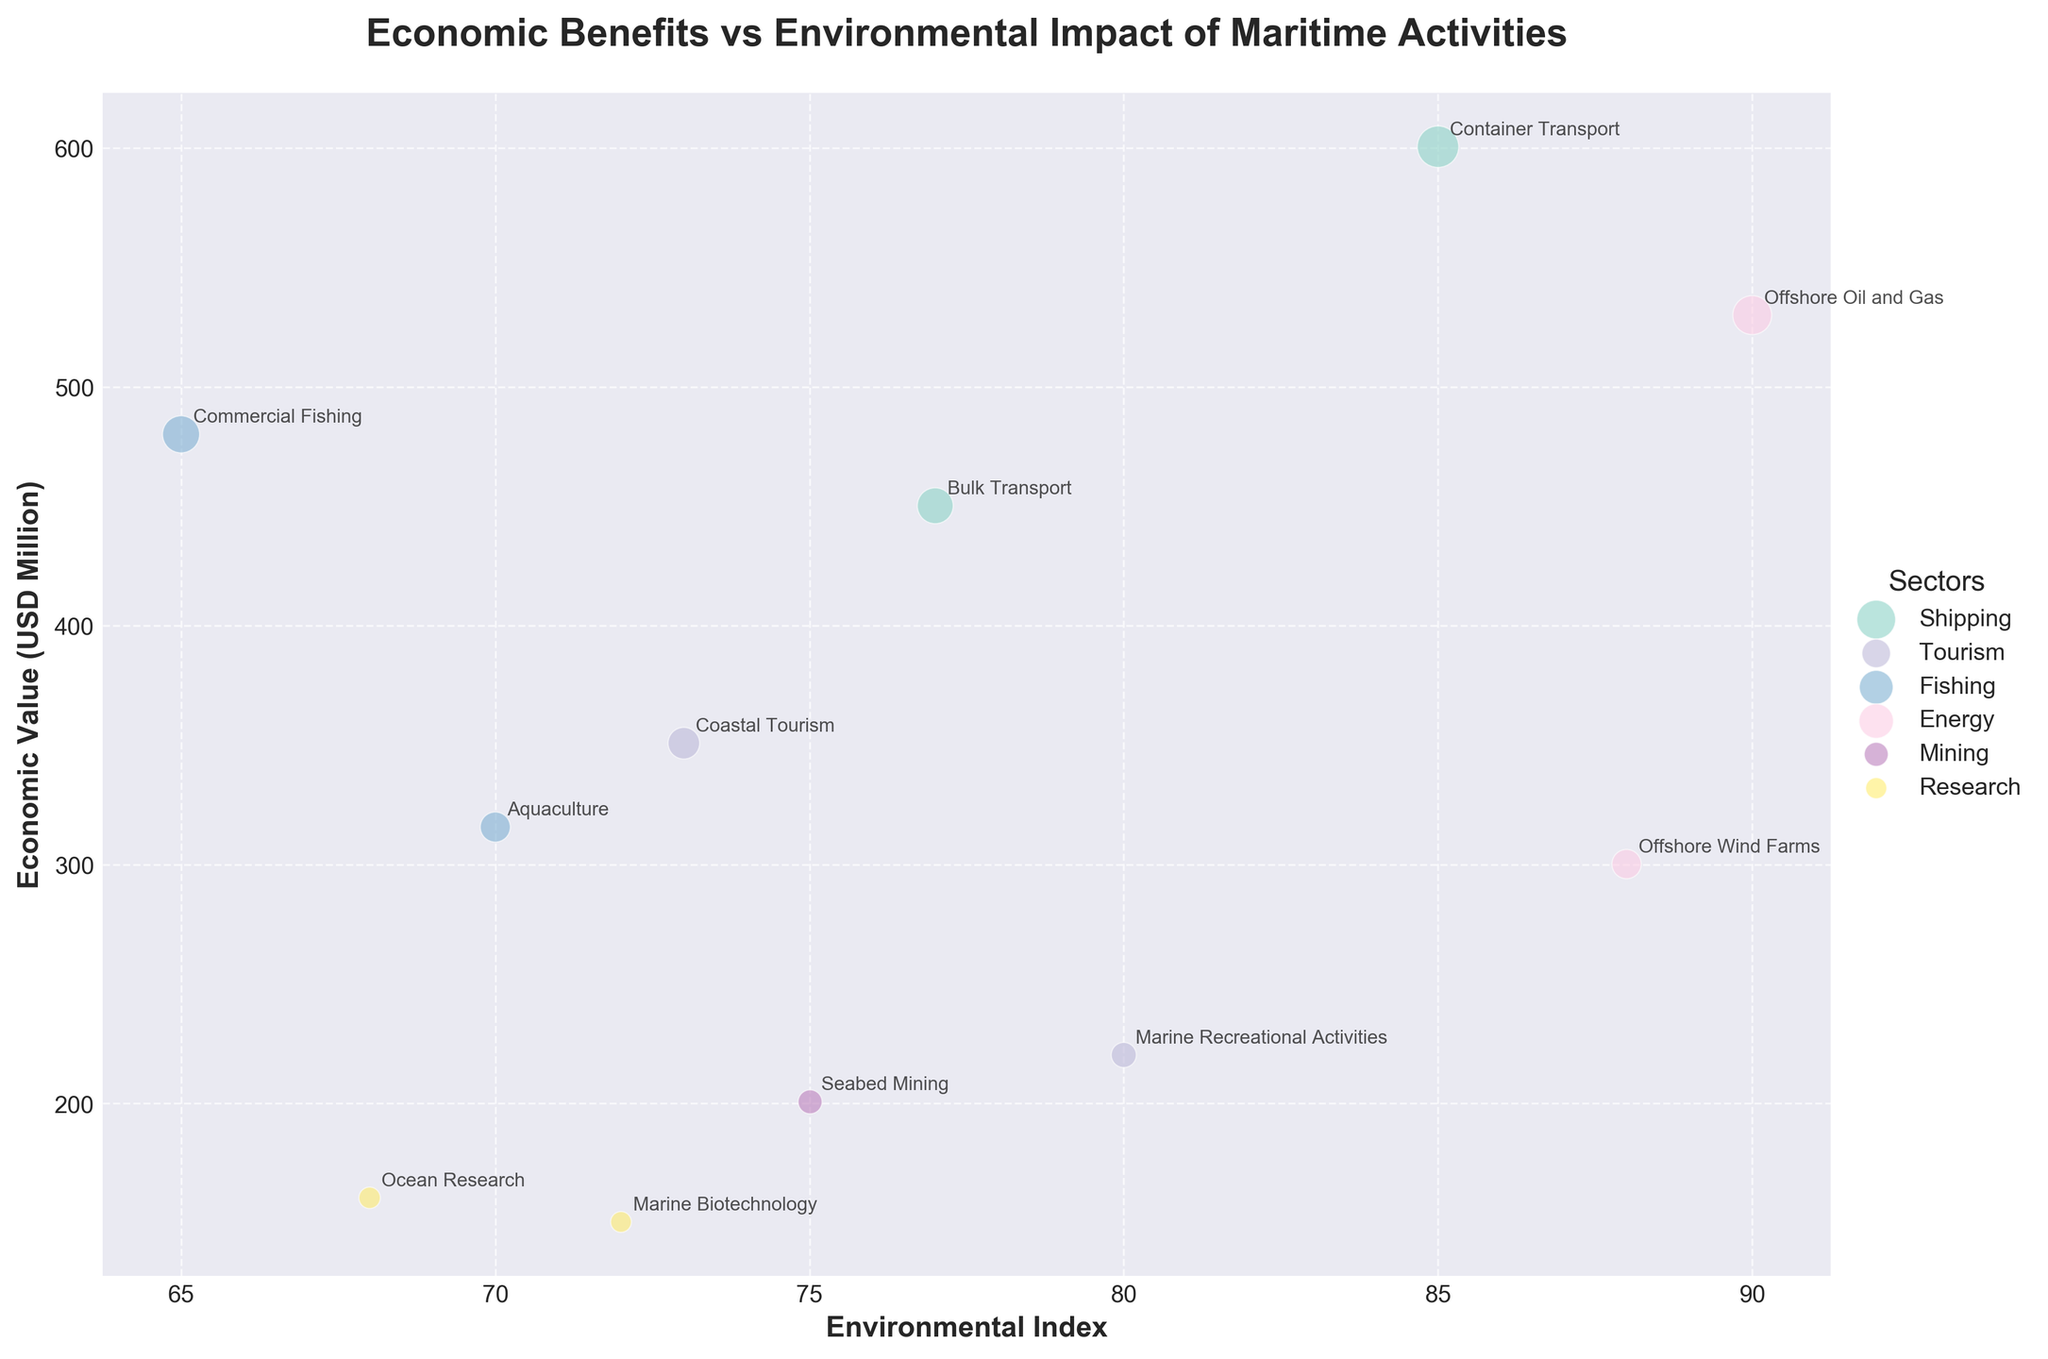What's the title of the chart? The title of the chart is displayed prominently at the top of the figure.
Answer: "Economic Benefits vs Environmental Impact of Maritime Activities" Which sector has the highest economic value? Identify the largest bubble on the vertical axis, which corresponds to the economic value. The "Offshore Oil and Gas" sector in Saudi Arabia has the highest value (530 USD Million).
Answer: Energy (Offshore Oil and Gas) How many different sectors are represented in the chart? Count the number of unique legends aside from the data points in the plot. There are 6 unique sectors (Shipping, Tourism, Fishing, Energy, Mining, Research).
Answer: 6 Which subsectors from the same country are depicted in the plot? Look for bubbles with similar colors and check their labels to see which country they belong to. Both "Ocean Research" and "Marine Biotechnology" subsectors from Canada are depicted.
Answer: Marine Biotechnology and Ocean Research Which sector has both the highest economic value and high environmental index? Cross-reference the highest economic value with corresponding environmental indices on the plot. The "Offshore Oil and Gas" sector has the highest economic value and a high environmental index of 90.
Answer: Energy (Offshore Oil and Gas) What is the average economic value of the tourism sector? Identify the economic values for all subsectors under "Tourism", then compute the average. (350.8 + 220.3) / 2 = 285.55 USD Million.
Answer: 285.55 Compare the economic values of "Commercial Fishing" in Japan and "Bulk Transport" in China. Which is higher? Locate both bubbles and compare their vertical positions to determine which economic value is higher. "Commercial Fishing" in Japan (480.1) is higher than "Bulk Transport" in China (450.2).
Answer: Commercial Fishing Which sector has the lowest environmental index? Identify the bubble with the lowest value on the horizontal axis. "Commercial Fishing" in Japan has the lowest environmental index of 65.
Answer: Fishing (Commercial Fishing) What is the total economic value of all shipping subsectors? Sum the economic values of "Container Transport" and "Bulk Transport". 600.5 + 450.2 = 1050.7 USD Million.
Answer: 1050.7 What are the two subsectors with the closest environmental indices? Compare the environmental indices and find the smallest difference. "Coastal Tourism" and "Seabed Mining" both closely align with indices of 73 and 75, respectively.
Answer: Coastal Tourism and Seabed Mining 